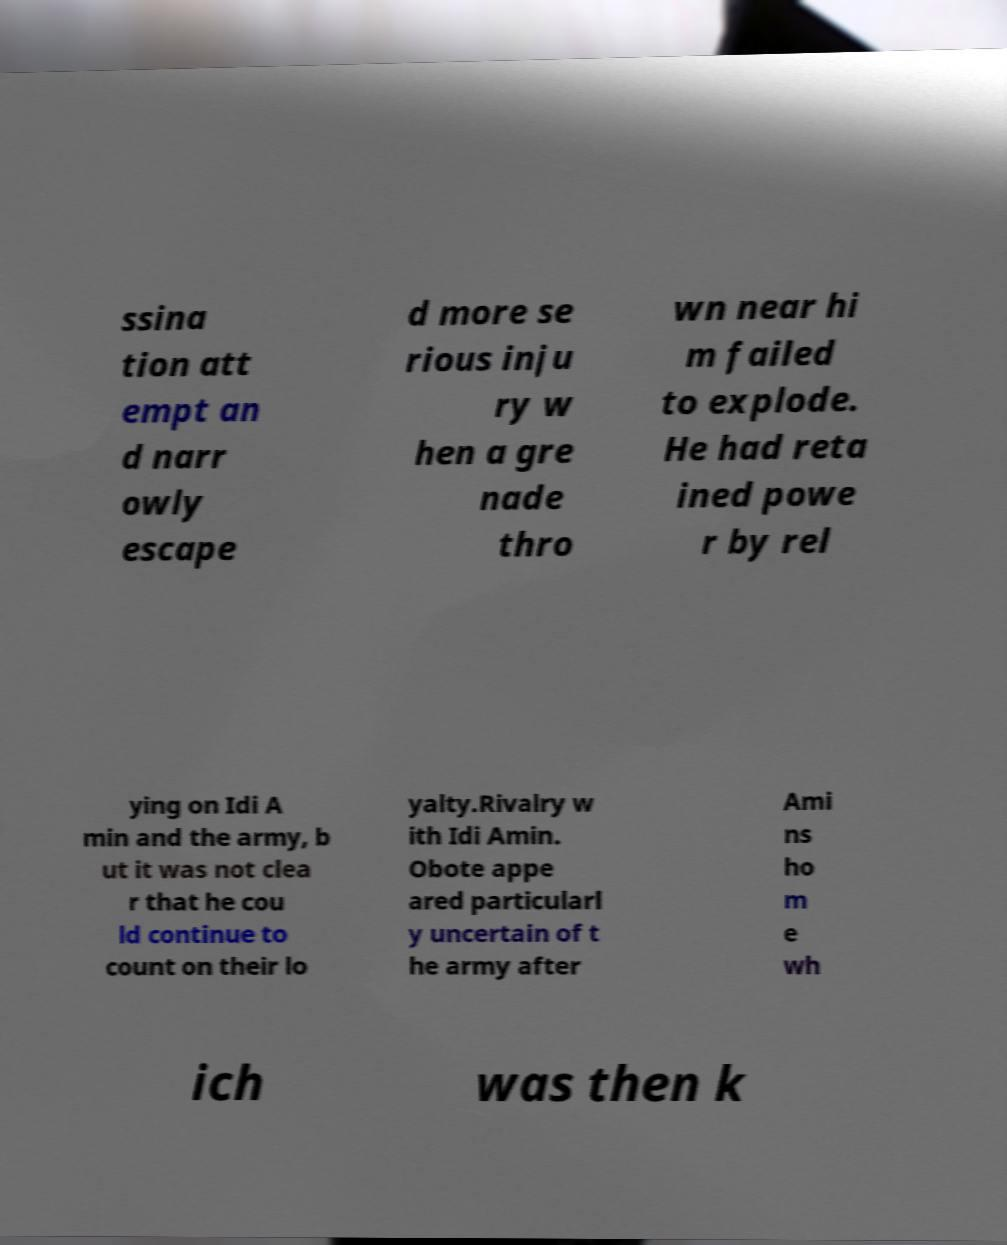There's text embedded in this image that I need extracted. Can you transcribe it verbatim? ssina tion att empt an d narr owly escape d more se rious inju ry w hen a gre nade thro wn near hi m failed to explode. He had reta ined powe r by rel ying on Idi A min and the army, b ut it was not clea r that he cou ld continue to count on their lo yalty.Rivalry w ith Idi Amin. Obote appe ared particularl y uncertain of t he army after Ami ns ho m e wh ich was then k 